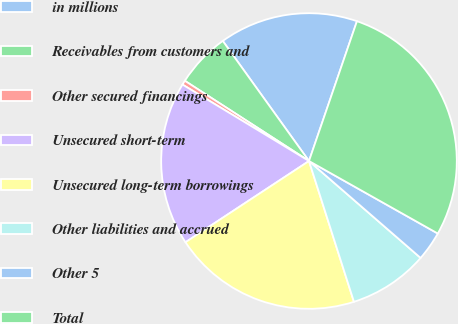Convert chart. <chart><loc_0><loc_0><loc_500><loc_500><pie_chart><fcel>in millions<fcel>Receivables from customers and<fcel>Other secured financings<fcel>Unsecured short-term<fcel>Unsecured long-term borrowings<fcel>Other liabilities and accrued<fcel>Other 5<fcel>Total<nl><fcel>15.17%<fcel>5.96%<fcel>0.48%<fcel>17.91%<fcel>20.66%<fcel>8.7%<fcel>3.22%<fcel>27.9%<nl></chart> 